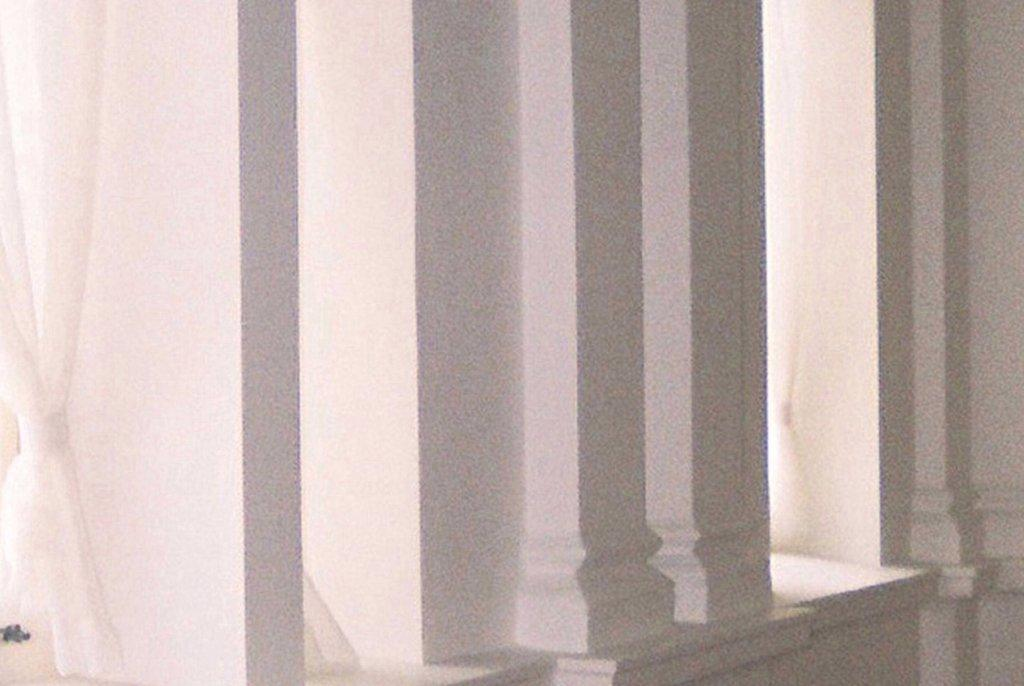What architectural features can be seen in the image? There are pillars in the image. What type of window treatment is present in the image? There are white color curtains in the image. Are there any snails crawling on the pillars in the image? There is no indication of snails or any other living creatures on the pillars in the image. 